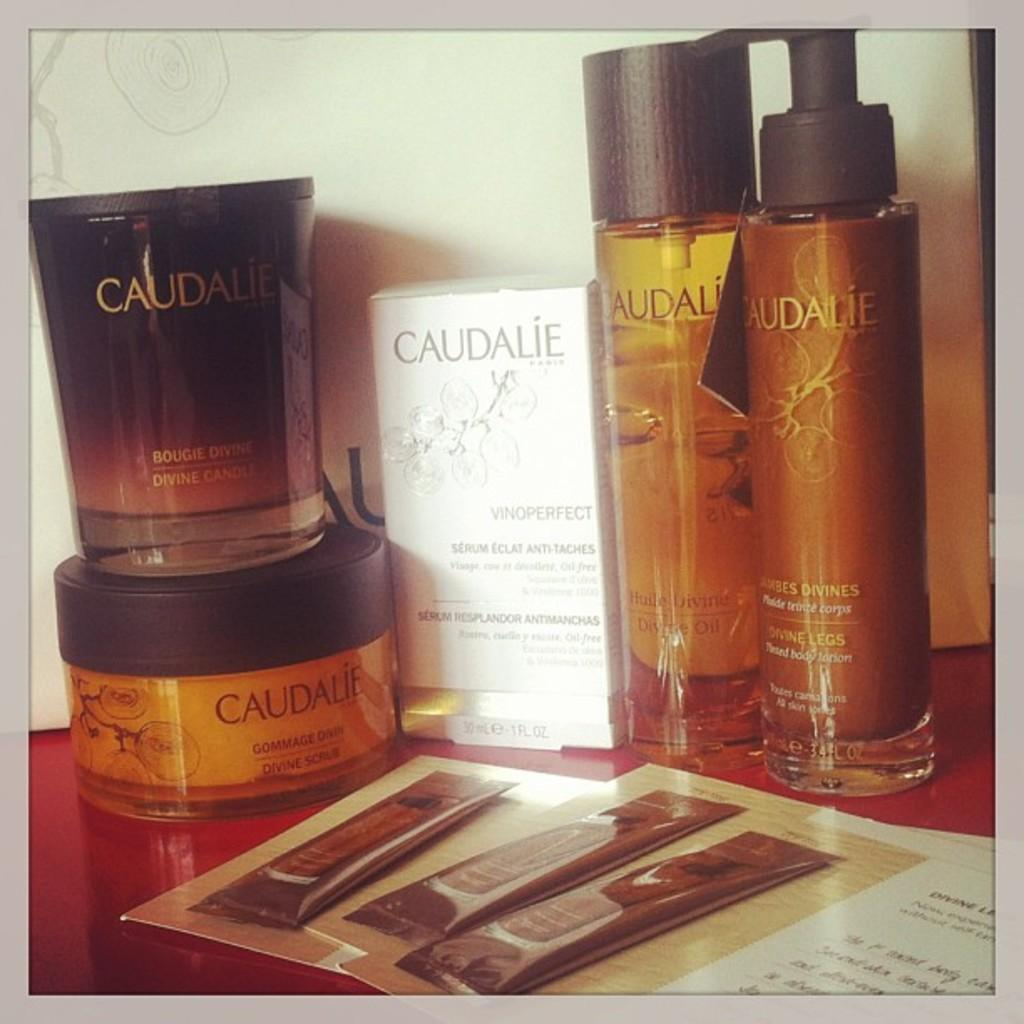<image>
Describe the image concisely. Caudalie products sitting on a red table and white background. 